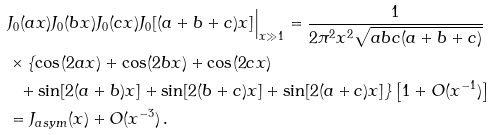Convert formula to latex. <formula><loc_0><loc_0><loc_500><loc_500>& J _ { 0 } ( a x ) J _ { 0 } ( b x ) J _ { 0 } ( c x ) J _ { 0 } [ ( a + b + c ) x ] \Big | _ { x \gg 1 } = \frac { 1 } { 2 \pi ^ { 2 } x ^ { 2 } \sqrt { a b c ( a + b + c ) } } \\ & \times \{ \cos ( 2 a x ) + \cos ( 2 b x ) + \cos ( 2 c x ) \\ & \ \ + \sin [ 2 ( a + b ) x ] + \sin [ 2 ( b + c ) x ] + \sin [ 2 ( a + c ) x ] \} \left [ 1 + O ( x ^ { - 1 } ) \right ] \\ & = J _ { a s y m } ( x ) + O ( x ^ { - 3 } ) \, .</formula> 